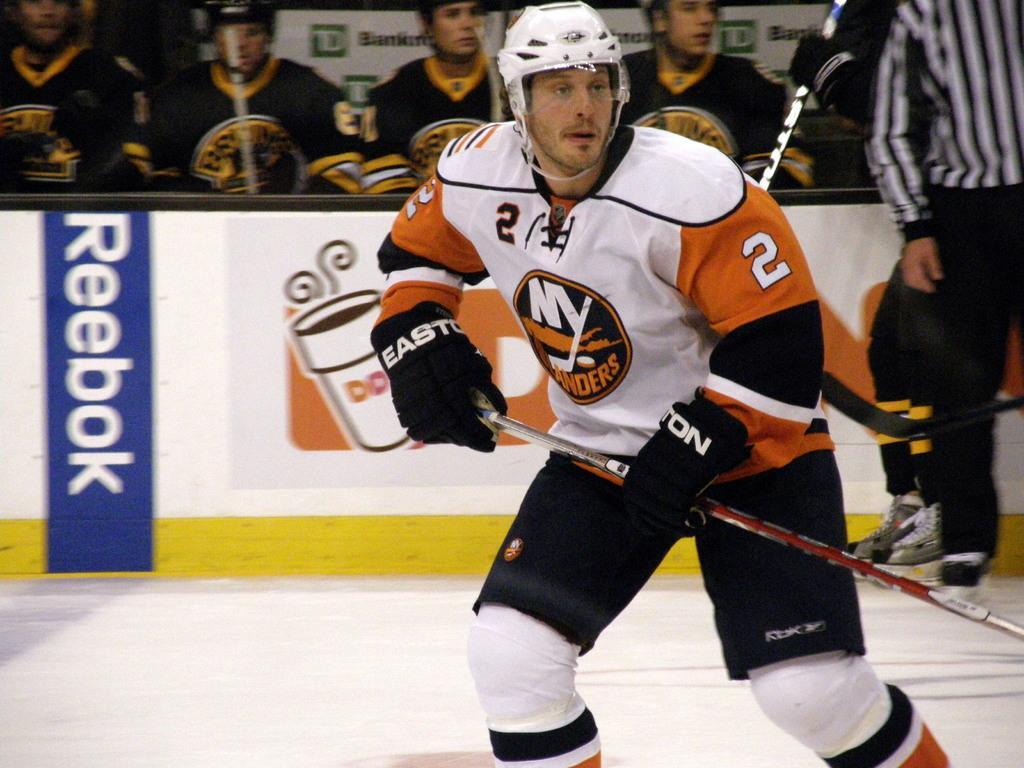Could you give a brief overview of what you see in this image? In this picture a man wearing hockey sports dress and holding a hockey stick in his hand and playing ice hockey, in the background there are five people who are also wearing hokey spots dress and holding bats in their hands, beside them there is a referee. 